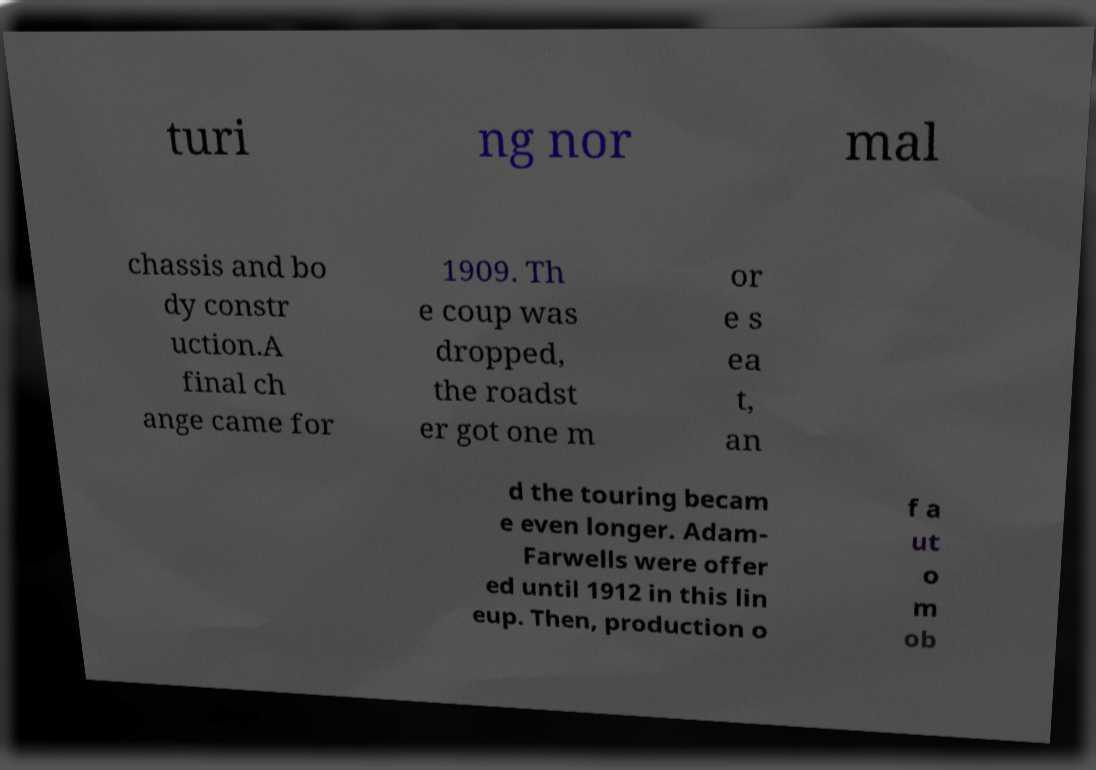Can you read and provide the text displayed in the image?This photo seems to have some interesting text. Can you extract and type it out for me? turi ng nor mal chassis and bo dy constr uction.A final ch ange came for 1909. Th e coup was dropped, the roadst er got one m or e s ea t, an d the touring becam e even longer. Adam- Farwells were offer ed until 1912 in this lin eup. Then, production o f a ut o m ob 